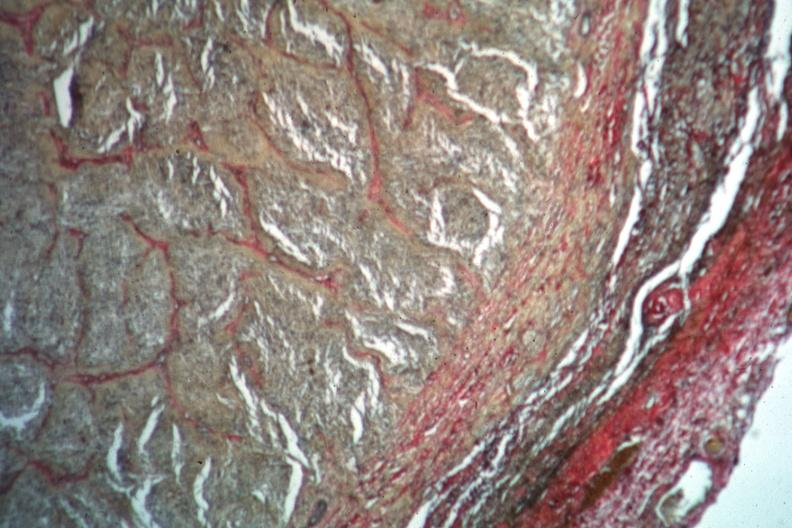s dysplastic present?
Answer the question using a single word or phrase. No 